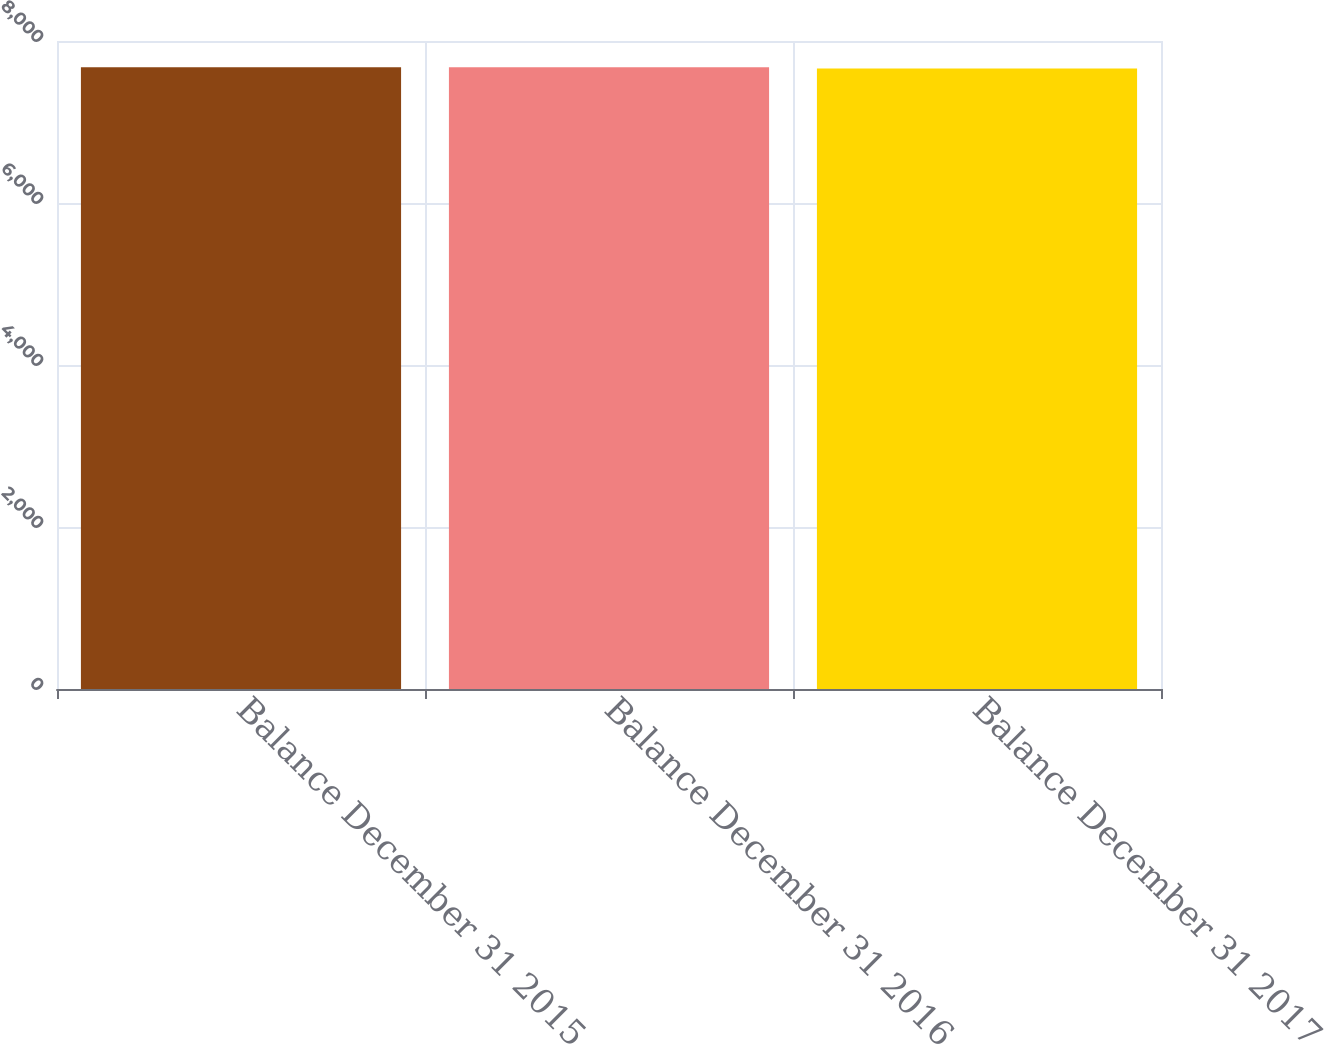Convert chart. <chart><loc_0><loc_0><loc_500><loc_500><bar_chart><fcel>Balance December 31 2015<fcel>Balance December 31 2016<fcel>Balance December 31 2017<nl><fcel>7676<fcel>7677.4<fcel>7662<nl></chart> 